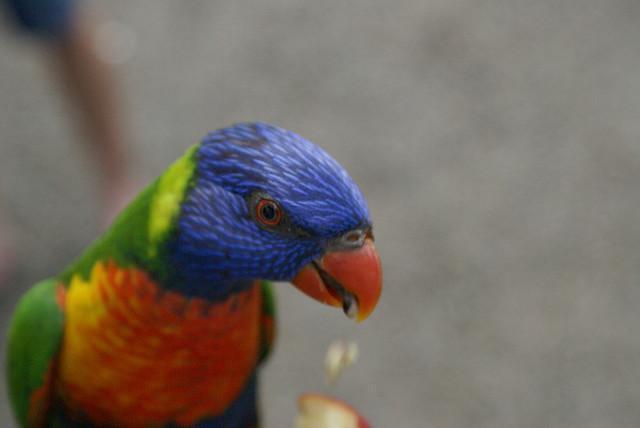Does the caption "The apple is on top of the bird." correctly depict the image?
Answer yes or no. No. 